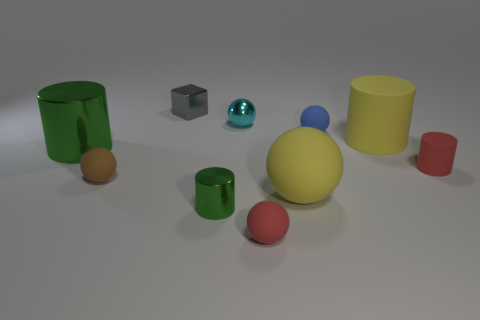Is there a sense of order or randomness to the placement of objects? The placement of the objects seems to be somewhat random, as there is no clear pattern or arrangement that would indicate a deliberate order. The objects are scattered across the surface without any apparent alignment or grouping, which might suggest a casual or arbitrary setting rather than a structured one. 